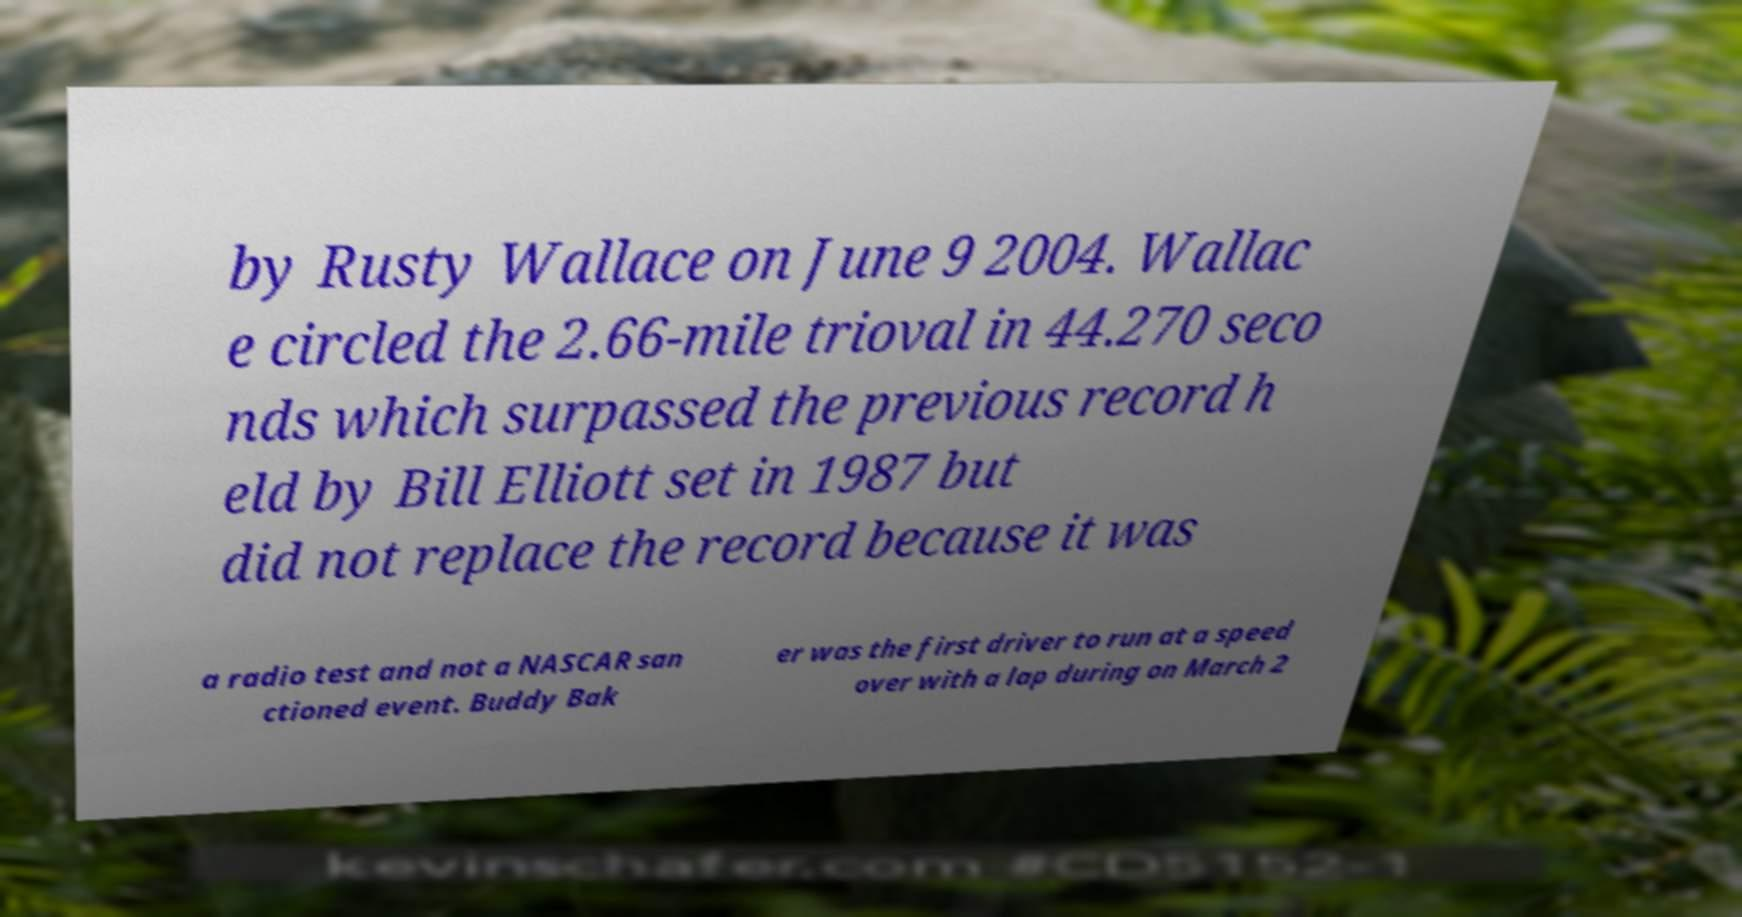There's text embedded in this image that I need extracted. Can you transcribe it verbatim? by Rusty Wallace on June 9 2004. Wallac e circled the 2.66-mile trioval in 44.270 seco nds which surpassed the previous record h eld by Bill Elliott set in 1987 but did not replace the record because it was a radio test and not a NASCAR san ctioned event. Buddy Bak er was the first driver to run at a speed over with a lap during on March 2 